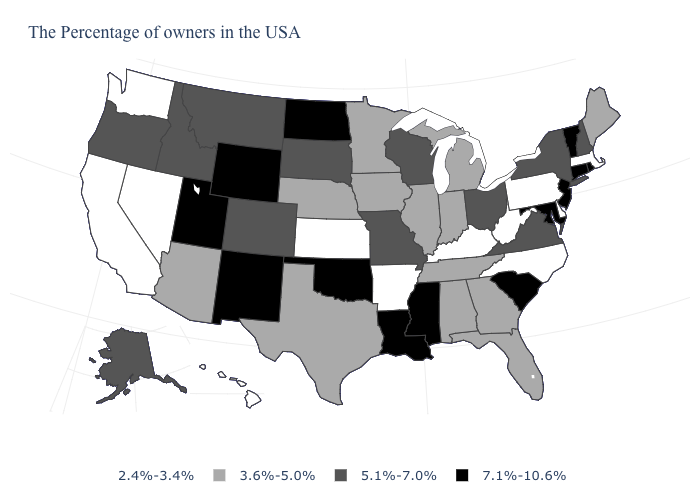What is the value of Connecticut?
Write a very short answer. 7.1%-10.6%. Among the states that border Virginia , which have the highest value?
Be succinct. Maryland. Among the states that border North Dakota , does South Dakota have the highest value?
Keep it brief. Yes. Which states hav the highest value in the South?
Write a very short answer. Maryland, South Carolina, Mississippi, Louisiana, Oklahoma. Which states hav the highest value in the Northeast?
Concise answer only. Rhode Island, Vermont, Connecticut, New Jersey. What is the lowest value in the USA?
Short answer required. 2.4%-3.4%. Does the first symbol in the legend represent the smallest category?
Quick response, please. Yes. What is the value of Iowa?
Short answer required. 3.6%-5.0%. What is the value of Oregon?
Give a very brief answer. 5.1%-7.0%. Does Wisconsin have a higher value than West Virginia?
Be succinct. Yes. Does New Hampshire have the lowest value in the Northeast?
Write a very short answer. No. Name the states that have a value in the range 7.1%-10.6%?
Quick response, please. Rhode Island, Vermont, Connecticut, New Jersey, Maryland, South Carolina, Mississippi, Louisiana, Oklahoma, North Dakota, Wyoming, New Mexico, Utah. Among the states that border Louisiana , which have the lowest value?
Quick response, please. Arkansas. What is the lowest value in the West?
Quick response, please. 2.4%-3.4%. Which states have the lowest value in the USA?
Give a very brief answer. Massachusetts, Delaware, Pennsylvania, North Carolina, West Virginia, Kentucky, Arkansas, Kansas, Nevada, California, Washington, Hawaii. 